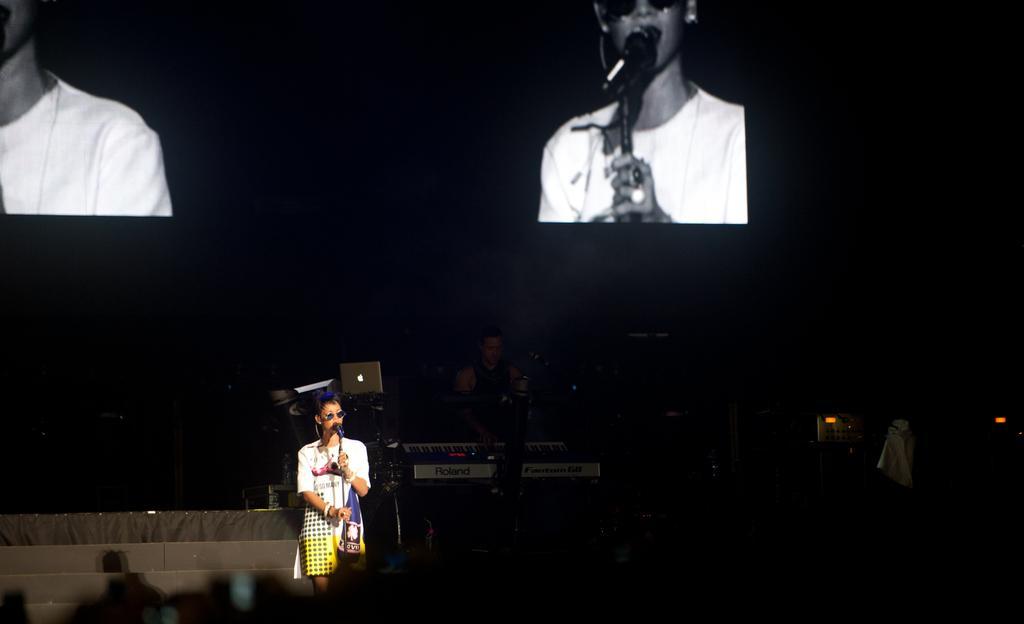Describe this image in one or two sentences. In the image we can see a woman standing, wearing clothes, spectacles and holding a microphone in the hands. Here we can see the screen, on the screen we can see the person wearing clothes and there are even other people. The corners of the image are dark. 